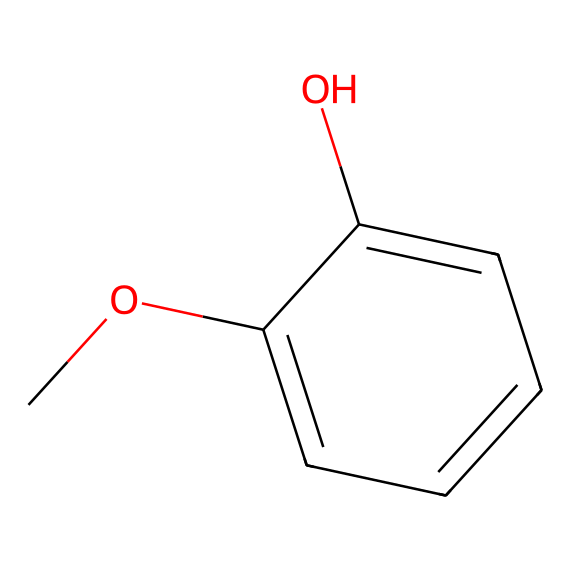What is the chemical name of this compound? The SMILES representation indicates a phenolic compound containing a hydroxyl group (-OH) and a methoxy group (-OCH3) on a benzene ring. This structure corresponds to a known compound called "guaiacol."
Answer: guaiacol How many carbon atoms are present in this chemical? By analyzing the SMILES notation, there are six carbon atoms in the benzene ring and two additional carbon atoms from the methoxy group. Therefore, there are a total of eight carbon atoms.
Answer: eight What type of functional groups are present in this compound? The compound contains a hydroxyl group (-OH) indicating that it is a phenol and a methoxy group (-OCH3), which is an ether. These functional groups significantly influence the chemical properties of the compound.
Answer: phenol, ether Does this compound occur naturally in wood smoke? Guaiacol is known to be a product of the pyrolysis of lignin and cellulose found in wood, thus it is commonly formed when wood is burned, including in campfires.
Answer: yes Is this phenolic compound potentially harmful? Phenolic compounds like guaiacol can be irritating to the respiratory tract and skin, and although it has some applications, its inhalation in significant quantities can lead to adverse health effects.
Answer: yes What is the role of phenolic compounds in smoke? Phenolic compounds contribute to the flavor and aroma of smoke, and they can also act as preservatives and anti-oxidants in different contexts, including food processing and preservation.
Answer: flavor, aroma, preservative How can the concentration of this compound be influenced during a campfire? The concentration of guaiacol can be influenced by factors such as the type of wood used, the temperature of combustion, and the amount of oxygen present during burning, affecting its formation and emission.
Answer: wood type, combustion temperature, oxygen level 